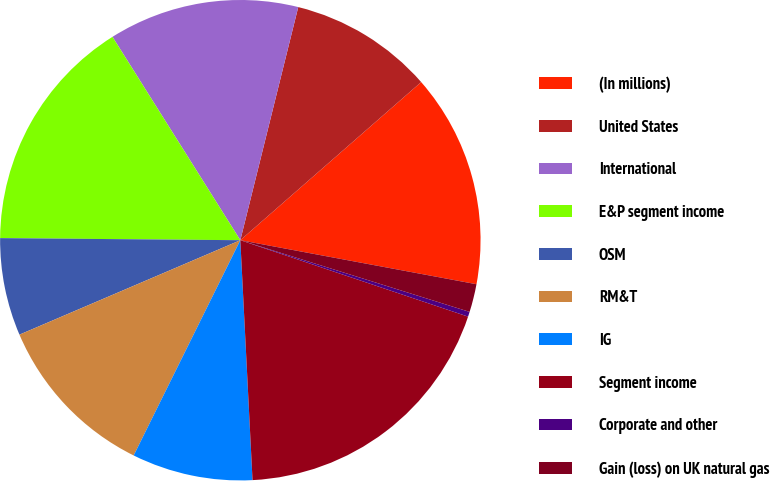Convert chart to OTSL. <chart><loc_0><loc_0><loc_500><loc_500><pie_chart><fcel>(In millions)<fcel>United States<fcel>International<fcel>E&P segment income<fcel>OSM<fcel>RM&T<fcel>IG<fcel>Segment income<fcel>Corporate and other<fcel>Gain (loss) on UK natural gas<nl><fcel>14.37%<fcel>9.69%<fcel>12.81%<fcel>15.93%<fcel>6.57%<fcel>11.25%<fcel>8.13%<fcel>19.04%<fcel>0.33%<fcel>1.89%<nl></chart> 